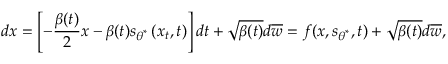<formula> <loc_0><loc_0><loc_500><loc_500>d x = \left [ - \frac { \beta ( t ) } { 2 } x - \beta ( t ) s _ { \theta ^ { * } } \left ( x _ { t } , t \right ) \right ] d t + \sqrt { \beta ( t ) } d \overline { w } = f ( x , s _ { \theta ^ { * } } , t ) + \sqrt { \beta ( t ) } d \overline { w } ,</formula> 